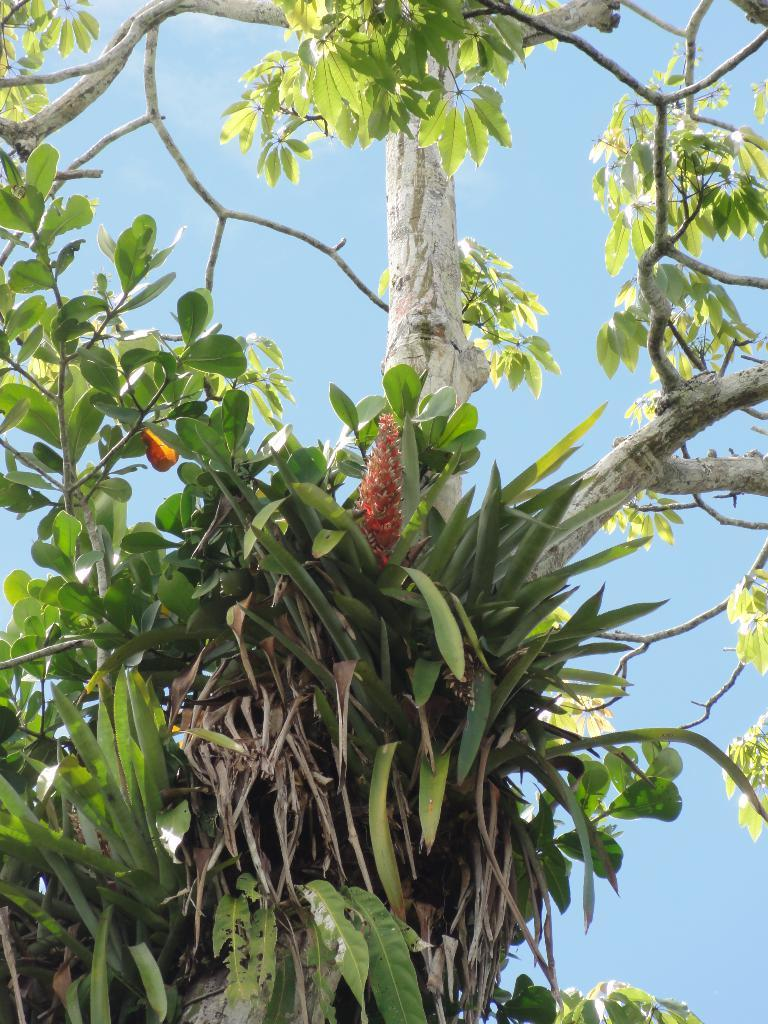What type of vegetation is present in the image? There is a plant and a tree in the image. What can be seen in the background of the image? The sky is visible in the background of the image. How many deer can be seen grazing near the plant in the image? There are no deer present in the image; it only features a plant and a tree. What type of fire is burning near the tree in the image? There is no fire present in the image; it only features a plant and a tree. 